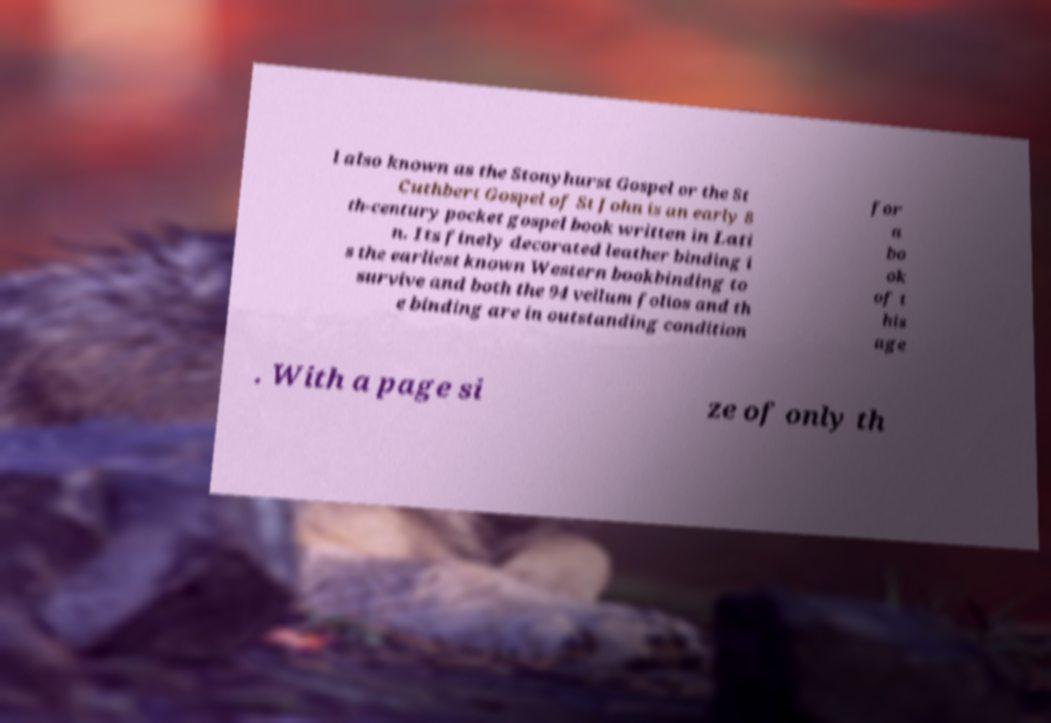For documentation purposes, I need the text within this image transcribed. Could you provide that? l also known as the Stonyhurst Gospel or the St Cuthbert Gospel of St John is an early 8 th-century pocket gospel book written in Lati n. Its finely decorated leather binding i s the earliest known Western bookbinding to survive and both the 94 vellum folios and th e binding are in outstanding condition for a bo ok of t his age . With a page si ze of only th 